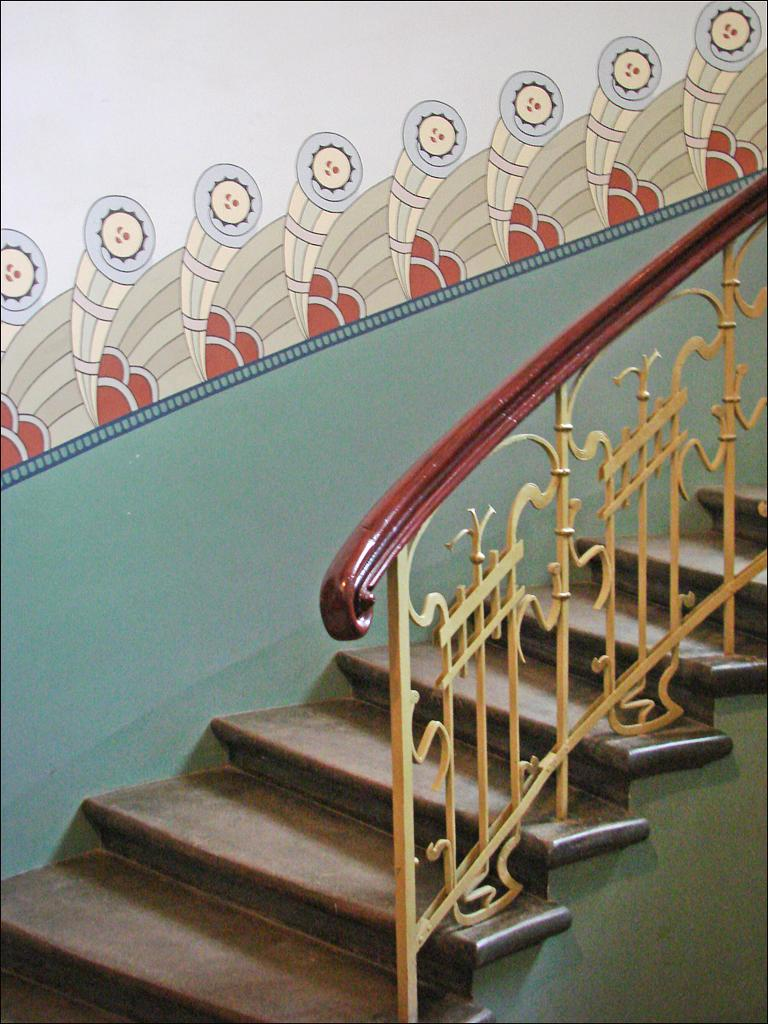What type of structure is present in the image? There is a staircase in the image. What feature does the staircase have? The staircase has a railing. What can be seen on the wall in the image? There are pictures on a wall in the image. What type of cart is used to transport the honey in the image? There is no cart or honey present in the image; it only features a staircase with a railing and pictures on a wall. 